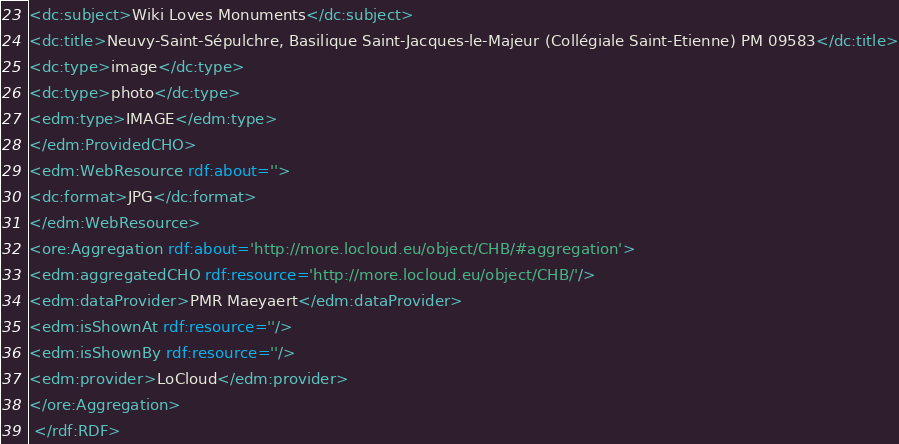Convert code to text. <code><loc_0><loc_0><loc_500><loc_500><_XML_><dc:subject>Wiki Loves Monuments</dc:subject>
<dc:title>Neuvy-Saint-Sépulchre, Basilique Saint-Jacques-le-Majeur (Collégiale Saint-Etienne) PM 09583</dc:title>
<dc:type>image</dc:type>
<dc:type>photo</dc:type>
<edm:type>IMAGE</edm:type>
</edm:ProvidedCHO>
<edm:WebResource rdf:about=''>
<dc:format>JPG</dc:format>
</edm:WebResource>
<ore:Aggregation rdf:about='http://more.locloud.eu/object/CHB/#aggregation'>
<edm:aggregatedCHO rdf:resource='http://more.locloud.eu/object/CHB/'/>
<edm:dataProvider>PMR Maeyaert</edm:dataProvider>
<edm:isShownAt rdf:resource=''/>
<edm:isShownBy rdf:resource=''/>
<edm:provider>LoCloud</edm:provider>
</ore:Aggregation>
 </rdf:RDF>
</code> 